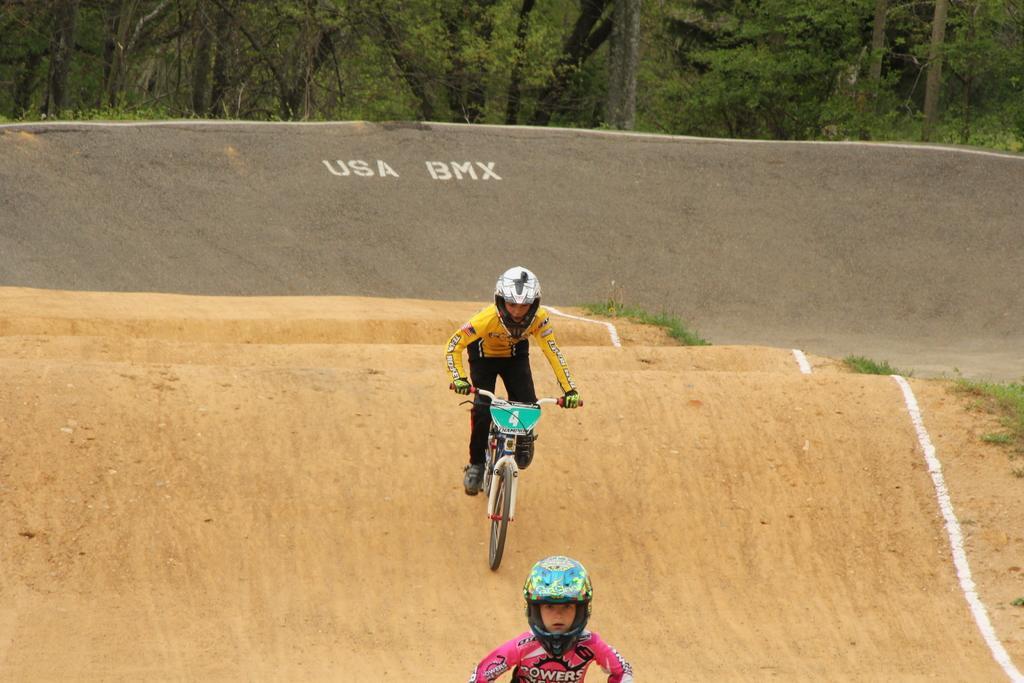In one or two sentences, can you explain what this image depicts? In this image we can see a person wearing a helmet riding a bicycle on the ground. In the foreground we can see a child wearing a helmet. On the backside we can see some grass, a wall with some text on it and a group of trees. 